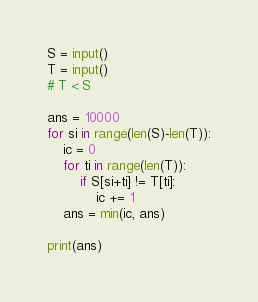<code> <loc_0><loc_0><loc_500><loc_500><_Python_>S = input()
T = input()
# T < S

ans = 10000
for si in range(len(S)-len(T)):
    ic = 0
    for ti in range(len(T)):
        if S[si+ti] != T[ti]:
            ic += 1
    ans = min(ic, ans)
        
print(ans)</code> 